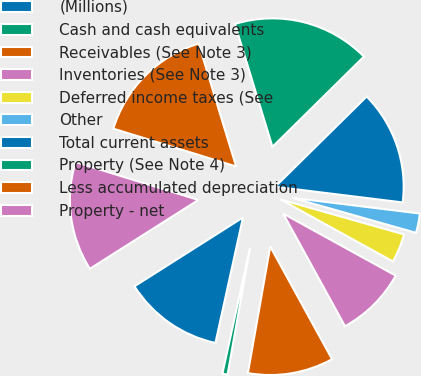Convert chart to OTSL. <chart><loc_0><loc_0><loc_500><loc_500><pie_chart><fcel>(Millions)<fcel>Cash and cash equivalents<fcel>Receivables (See Note 3)<fcel>Inventories (See Note 3)<fcel>Deferred income taxes (See<fcel>Other<fcel>Total current assets<fcel>Property (See Note 4)<fcel>Less accumulated depreciation<fcel>Property - net<nl><fcel>12.56%<fcel>0.66%<fcel>10.77%<fcel>8.99%<fcel>3.63%<fcel>2.44%<fcel>14.34%<fcel>17.32%<fcel>15.53%<fcel>13.75%<nl></chart> 